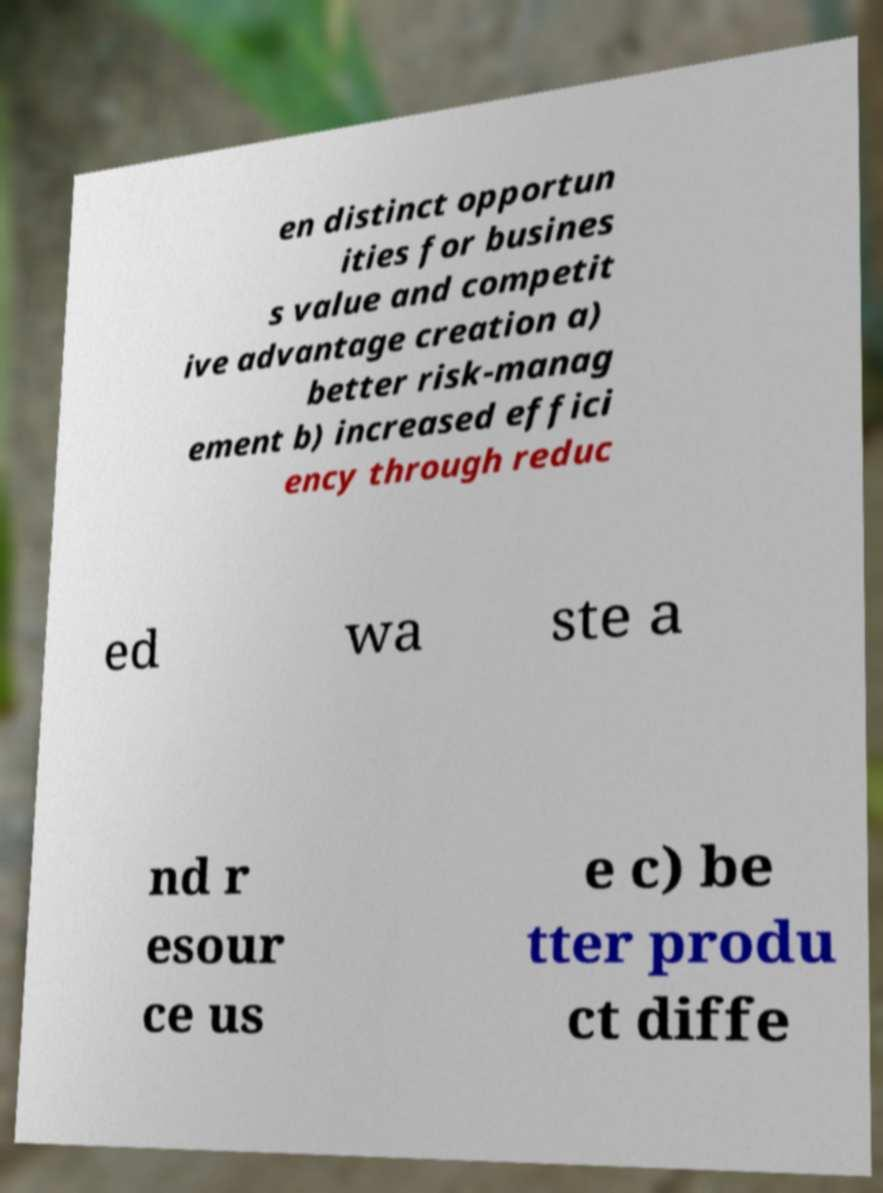Can you read and provide the text displayed in the image?This photo seems to have some interesting text. Can you extract and type it out for me? en distinct opportun ities for busines s value and competit ive advantage creation a) better risk-manag ement b) increased effici ency through reduc ed wa ste a nd r esour ce us e c) be tter produ ct diffe 